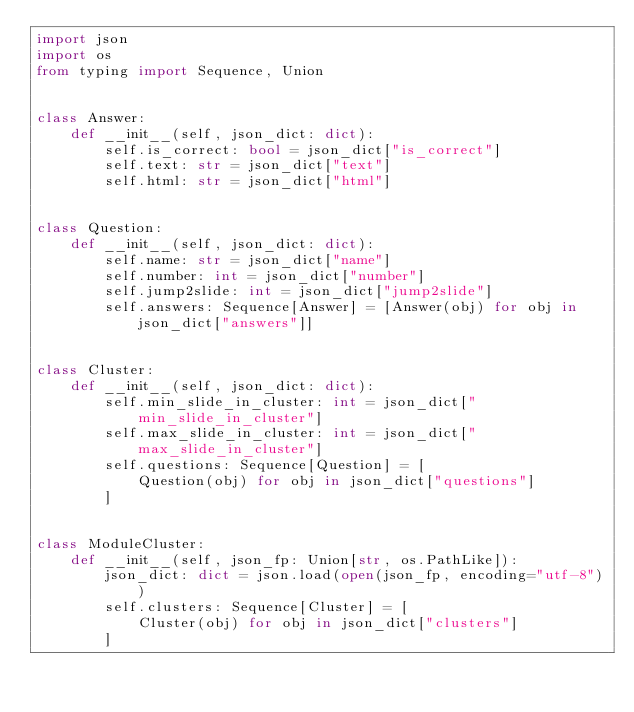Convert code to text. <code><loc_0><loc_0><loc_500><loc_500><_Python_>import json
import os
from typing import Sequence, Union


class Answer:
    def __init__(self, json_dict: dict):
        self.is_correct: bool = json_dict["is_correct"]
        self.text: str = json_dict["text"]
        self.html: str = json_dict["html"]


class Question:
    def __init__(self, json_dict: dict):
        self.name: str = json_dict["name"]
        self.number: int = json_dict["number"]
        self.jump2slide: int = json_dict["jump2slide"]
        self.answers: Sequence[Answer] = [Answer(obj) for obj in json_dict["answers"]]


class Cluster:
    def __init__(self, json_dict: dict):
        self.min_slide_in_cluster: int = json_dict["min_slide_in_cluster"]
        self.max_slide_in_cluster: int = json_dict["max_slide_in_cluster"]
        self.questions: Sequence[Question] = [
            Question(obj) for obj in json_dict["questions"]
        ]


class ModuleCluster:
    def __init__(self, json_fp: Union[str, os.PathLike]):
        json_dict: dict = json.load(open(json_fp, encoding="utf-8"))
        self.clusters: Sequence[Cluster] = [
            Cluster(obj) for obj in json_dict["clusters"]
        ]
</code> 